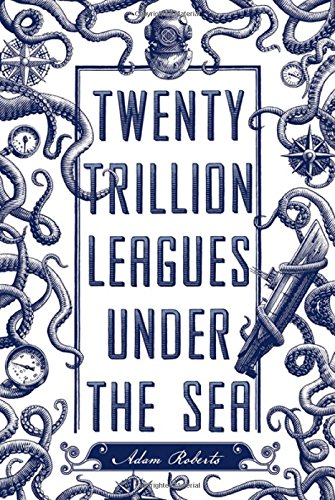What inspired the unique twist on the original Verne title in 'Twenty Trillion Leagues Under the Sea'? The title is a playful and hyperbolic allusion to Jules Verne's 'Twenty Thousand Leagues Under the Sea,' suggesting a vastly grander and possibly more fantastical scope for underwater adventure. Could this book be considered a modern tribute to classic adventure novels? Certainly, it carries the essence of the classic adventure novel into a contemporary setting, creating a bridge between the cherished storytelling techniques of the past and the imaginative possibilities of the present. 